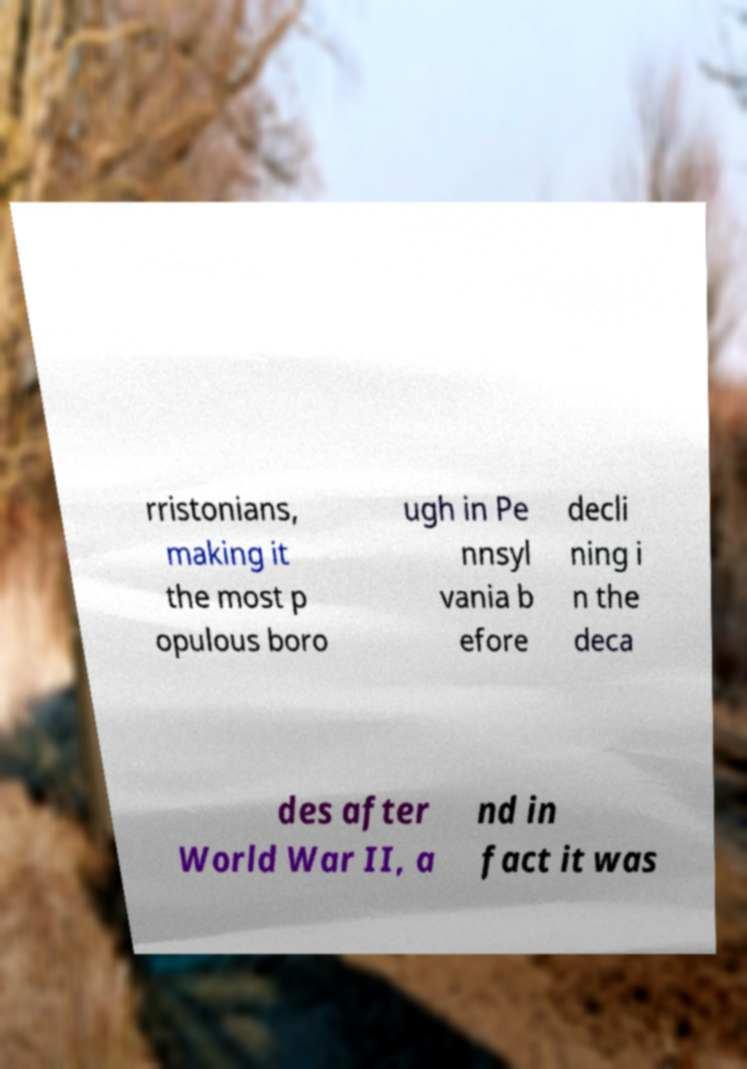What messages or text are displayed in this image? I need them in a readable, typed format. rristonians, making it the most p opulous boro ugh in Pe nnsyl vania b efore decli ning i n the deca des after World War II, a nd in fact it was 